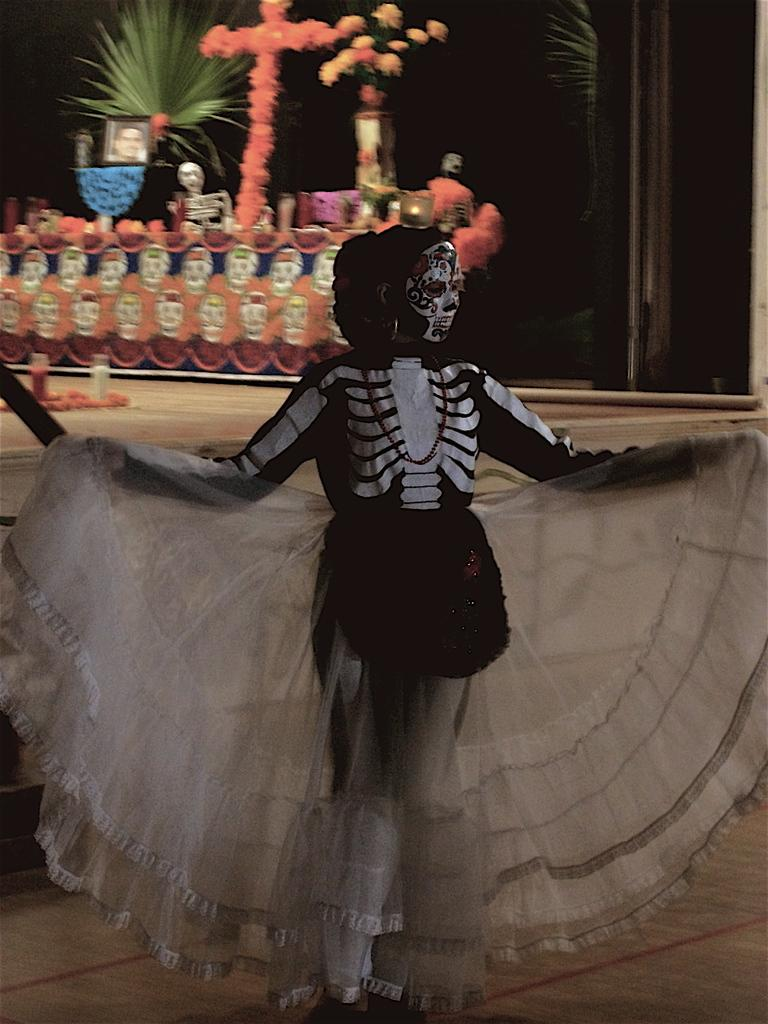What is the person in the image wearing? The person in the image is wearing a costume. What can be seen in the background of the image? There are plants, flowers, and objects in the background of the image. What type of ear is visible on the costume in the image? There is no ear visible on the costume in the image. How many examples of the costume can be seen in the image? There is only one person wearing a costume in the image, so there is only one example. 